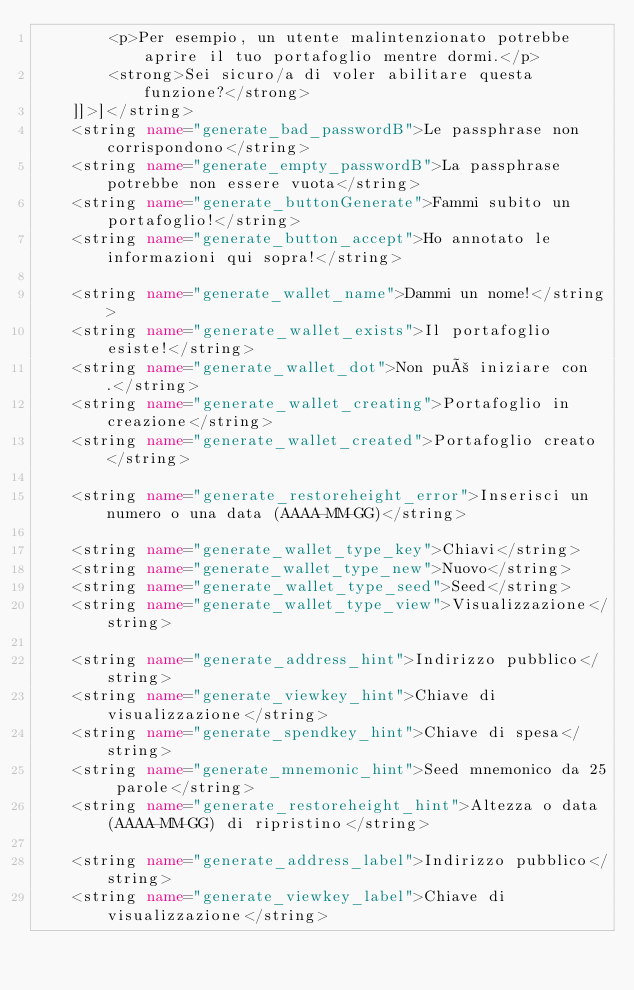<code> <loc_0><loc_0><loc_500><loc_500><_XML_>        <p>Per esempio, un utente malintenzionato potrebbe aprire il tuo portafoglio mentre dormi.</p>
        <strong>Sei sicuro/a di voler abilitare questa funzione?</strong>
    ]]>]</string>
    <string name="generate_bad_passwordB">Le passphrase non corrispondono</string>
    <string name="generate_empty_passwordB">La passphrase potrebbe non essere vuota</string>
    <string name="generate_buttonGenerate">Fammi subito un portafoglio!</string>
    <string name="generate_button_accept">Ho annotato le informazioni qui sopra!</string>

    <string name="generate_wallet_name">Dammi un nome!</string>
    <string name="generate_wallet_exists">Il portafoglio esiste!</string>
    <string name="generate_wallet_dot">Non può iniziare con .</string>
    <string name="generate_wallet_creating">Portafoglio in creazione</string>
    <string name="generate_wallet_created">Portafoglio creato</string>

    <string name="generate_restoreheight_error">Inserisci un numero o una data (AAAA-MM-GG)</string>

    <string name="generate_wallet_type_key">Chiavi</string>
    <string name="generate_wallet_type_new">Nuovo</string>
    <string name="generate_wallet_type_seed">Seed</string>
    <string name="generate_wallet_type_view">Visualizzazione</string>

    <string name="generate_address_hint">Indirizzo pubblico</string>
    <string name="generate_viewkey_hint">Chiave di visualizzazione</string>
    <string name="generate_spendkey_hint">Chiave di spesa</string>
    <string name="generate_mnemonic_hint">Seed mnemonico da 25 parole</string>
    <string name="generate_restoreheight_hint">Altezza o data (AAAA-MM-GG) di ripristino</string>

    <string name="generate_address_label">Indirizzo pubblico</string>
    <string name="generate_viewkey_label">Chiave di visualizzazione</string></code> 